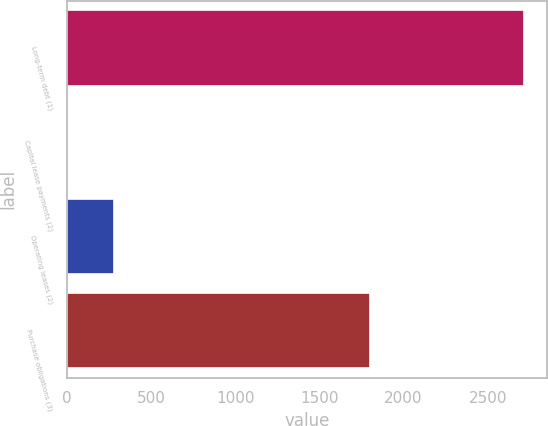Convert chart. <chart><loc_0><loc_0><loc_500><loc_500><bar_chart><fcel>Long-term debt (1)<fcel>Capital lease payments (2)<fcel>Operating leases (2)<fcel>Purchase obligations (3)<nl><fcel>2717<fcel>7<fcel>278<fcel>1803<nl></chart> 